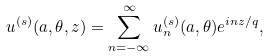<formula> <loc_0><loc_0><loc_500><loc_500>u ^ { ( s ) } ( a , \theta , z ) = \sum _ { n = - \infty } ^ { \infty } u ^ { ( s ) } _ { n } ( a , \theta ) e ^ { i n z / q } ,</formula> 